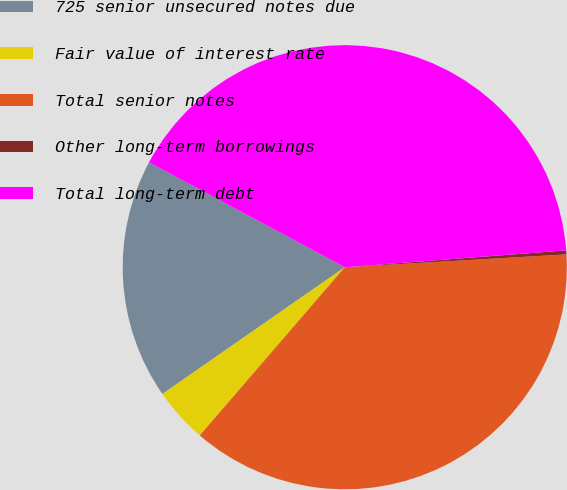Convert chart to OTSL. <chart><loc_0><loc_0><loc_500><loc_500><pie_chart><fcel>725 senior unsecured notes due<fcel>Fair value of interest rate<fcel>Total senior notes<fcel>Other long-term borrowings<fcel>Total long-term debt<nl><fcel>17.5%<fcel>4.01%<fcel>37.24%<fcel>0.29%<fcel>40.96%<nl></chart> 